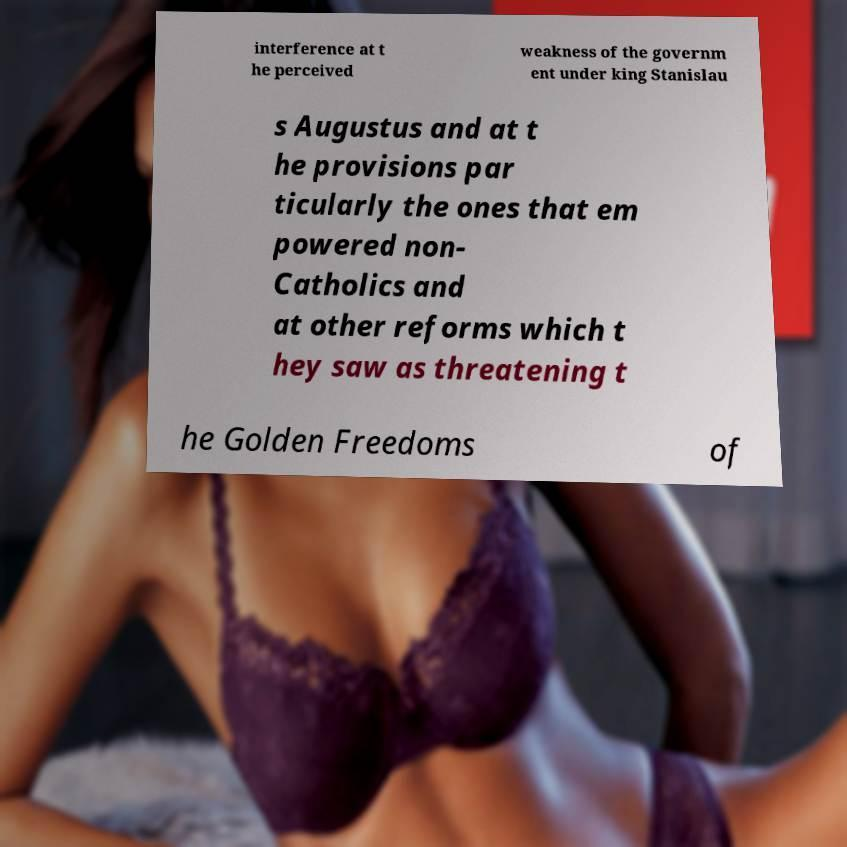Could you extract and type out the text from this image? interference at t he perceived weakness of the governm ent under king Stanislau s Augustus and at t he provisions par ticularly the ones that em powered non- Catholics and at other reforms which t hey saw as threatening t he Golden Freedoms of 